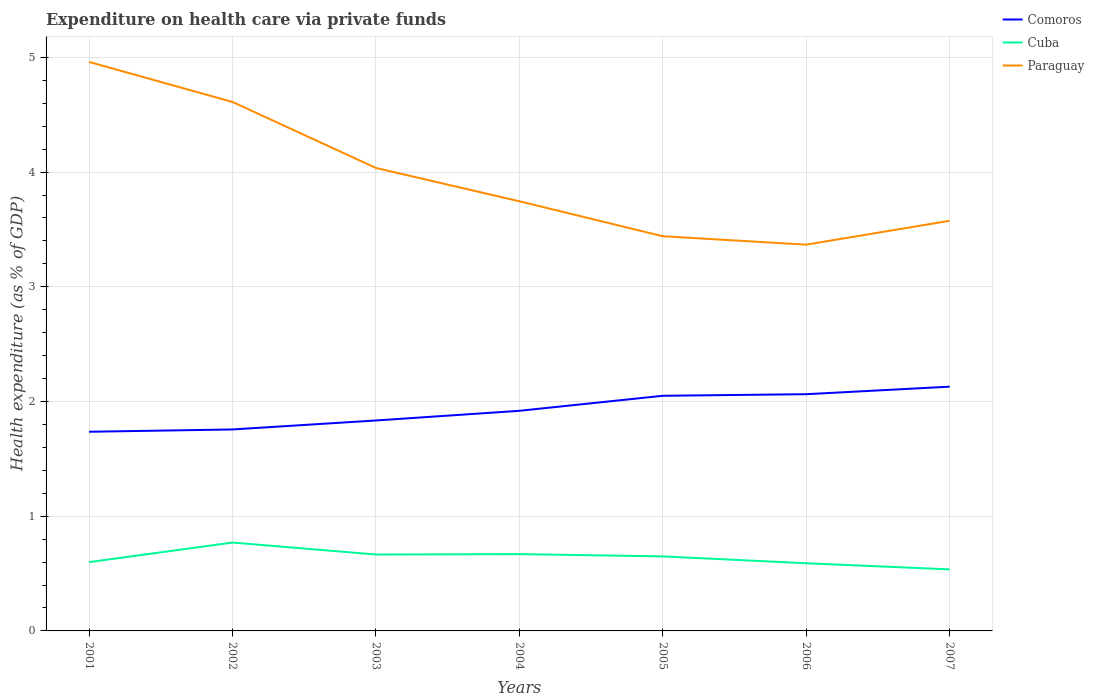How many different coloured lines are there?
Give a very brief answer. 3. Is the number of lines equal to the number of legend labels?
Provide a succinct answer. Yes. Across all years, what is the maximum expenditure made on health care in Comoros?
Your answer should be compact. 1.74. What is the total expenditure made on health care in Paraguay in the graph?
Provide a short and direct response. 1.21. What is the difference between the highest and the second highest expenditure made on health care in Cuba?
Ensure brevity in your answer.  0.23. How many lines are there?
Your response must be concise. 3. How many years are there in the graph?
Make the answer very short. 7. What is the difference between two consecutive major ticks on the Y-axis?
Make the answer very short. 1. Are the values on the major ticks of Y-axis written in scientific E-notation?
Keep it short and to the point. No. Does the graph contain any zero values?
Ensure brevity in your answer.  No. Does the graph contain grids?
Provide a succinct answer. Yes. How many legend labels are there?
Your answer should be compact. 3. How are the legend labels stacked?
Ensure brevity in your answer.  Vertical. What is the title of the graph?
Keep it short and to the point. Expenditure on health care via private funds. What is the label or title of the X-axis?
Give a very brief answer. Years. What is the label or title of the Y-axis?
Give a very brief answer. Health expenditure (as % of GDP). What is the Health expenditure (as % of GDP) in Comoros in 2001?
Provide a succinct answer. 1.74. What is the Health expenditure (as % of GDP) in Cuba in 2001?
Provide a short and direct response. 0.6. What is the Health expenditure (as % of GDP) of Paraguay in 2001?
Offer a terse response. 4.96. What is the Health expenditure (as % of GDP) of Comoros in 2002?
Offer a very short reply. 1.76. What is the Health expenditure (as % of GDP) in Cuba in 2002?
Your response must be concise. 0.77. What is the Health expenditure (as % of GDP) in Paraguay in 2002?
Ensure brevity in your answer.  4.61. What is the Health expenditure (as % of GDP) of Comoros in 2003?
Your response must be concise. 1.83. What is the Health expenditure (as % of GDP) in Cuba in 2003?
Provide a succinct answer. 0.67. What is the Health expenditure (as % of GDP) of Paraguay in 2003?
Offer a terse response. 4.04. What is the Health expenditure (as % of GDP) of Comoros in 2004?
Offer a terse response. 1.92. What is the Health expenditure (as % of GDP) in Cuba in 2004?
Offer a terse response. 0.67. What is the Health expenditure (as % of GDP) in Paraguay in 2004?
Give a very brief answer. 3.75. What is the Health expenditure (as % of GDP) in Comoros in 2005?
Ensure brevity in your answer.  2.05. What is the Health expenditure (as % of GDP) of Cuba in 2005?
Ensure brevity in your answer.  0.65. What is the Health expenditure (as % of GDP) of Paraguay in 2005?
Your answer should be very brief. 3.44. What is the Health expenditure (as % of GDP) in Comoros in 2006?
Make the answer very short. 2.06. What is the Health expenditure (as % of GDP) of Cuba in 2006?
Your answer should be very brief. 0.59. What is the Health expenditure (as % of GDP) of Paraguay in 2006?
Keep it short and to the point. 3.37. What is the Health expenditure (as % of GDP) of Comoros in 2007?
Provide a succinct answer. 2.13. What is the Health expenditure (as % of GDP) in Cuba in 2007?
Ensure brevity in your answer.  0.54. What is the Health expenditure (as % of GDP) of Paraguay in 2007?
Keep it short and to the point. 3.58. Across all years, what is the maximum Health expenditure (as % of GDP) in Comoros?
Your answer should be compact. 2.13. Across all years, what is the maximum Health expenditure (as % of GDP) of Cuba?
Provide a short and direct response. 0.77. Across all years, what is the maximum Health expenditure (as % of GDP) in Paraguay?
Provide a short and direct response. 4.96. Across all years, what is the minimum Health expenditure (as % of GDP) of Comoros?
Your answer should be very brief. 1.74. Across all years, what is the minimum Health expenditure (as % of GDP) in Cuba?
Give a very brief answer. 0.54. Across all years, what is the minimum Health expenditure (as % of GDP) in Paraguay?
Provide a short and direct response. 3.37. What is the total Health expenditure (as % of GDP) in Comoros in the graph?
Make the answer very short. 13.49. What is the total Health expenditure (as % of GDP) of Cuba in the graph?
Provide a short and direct response. 4.48. What is the total Health expenditure (as % of GDP) in Paraguay in the graph?
Make the answer very short. 27.74. What is the difference between the Health expenditure (as % of GDP) of Comoros in 2001 and that in 2002?
Give a very brief answer. -0.02. What is the difference between the Health expenditure (as % of GDP) in Cuba in 2001 and that in 2002?
Give a very brief answer. -0.17. What is the difference between the Health expenditure (as % of GDP) of Paraguay in 2001 and that in 2002?
Offer a very short reply. 0.35. What is the difference between the Health expenditure (as % of GDP) of Comoros in 2001 and that in 2003?
Offer a very short reply. -0.1. What is the difference between the Health expenditure (as % of GDP) in Cuba in 2001 and that in 2003?
Your answer should be very brief. -0.07. What is the difference between the Health expenditure (as % of GDP) of Paraguay in 2001 and that in 2003?
Make the answer very short. 0.92. What is the difference between the Health expenditure (as % of GDP) of Comoros in 2001 and that in 2004?
Ensure brevity in your answer.  -0.18. What is the difference between the Health expenditure (as % of GDP) of Cuba in 2001 and that in 2004?
Ensure brevity in your answer.  -0.07. What is the difference between the Health expenditure (as % of GDP) of Paraguay in 2001 and that in 2004?
Ensure brevity in your answer.  1.21. What is the difference between the Health expenditure (as % of GDP) of Comoros in 2001 and that in 2005?
Ensure brevity in your answer.  -0.31. What is the difference between the Health expenditure (as % of GDP) in Cuba in 2001 and that in 2005?
Offer a very short reply. -0.05. What is the difference between the Health expenditure (as % of GDP) in Paraguay in 2001 and that in 2005?
Give a very brief answer. 1.52. What is the difference between the Health expenditure (as % of GDP) of Comoros in 2001 and that in 2006?
Your answer should be very brief. -0.33. What is the difference between the Health expenditure (as % of GDP) in Cuba in 2001 and that in 2006?
Keep it short and to the point. 0.01. What is the difference between the Health expenditure (as % of GDP) in Paraguay in 2001 and that in 2006?
Ensure brevity in your answer.  1.59. What is the difference between the Health expenditure (as % of GDP) of Comoros in 2001 and that in 2007?
Give a very brief answer. -0.39. What is the difference between the Health expenditure (as % of GDP) of Cuba in 2001 and that in 2007?
Ensure brevity in your answer.  0.06. What is the difference between the Health expenditure (as % of GDP) of Paraguay in 2001 and that in 2007?
Give a very brief answer. 1.38. What is the difference between the Health expenditure (as % of GDP) in Comoros in 2002 and that in 2003?
Your answer should be very brief. -0.08. What is the difference between the Health expenditure (as % of GDP) of Cuba in 2002 and that in 2003?
Keep it short and to the point. 0.1. What is the difference between the Health expenditure (as % of GDP) in Paraguay in 2002 and that in 2003?
Keep it short and to the point. 0.58. What is the difference between the Health expenditure (as % of GDP) in Comoros in 2002 and that in 2004?
Offer a terse response. -0.16. What is the difference between the Health expenditure (as % of GDP) of Cuba in 2002 and that in 2004?
Keep it short and to the point. 0.1. What is the difference between the Health expenditure (as % of GDP) in Paraguay in 2002 and that in 2004?
Provide a succinct answer. 0.87. What is the difference between the Health expenditure (as % of GDP) in Comoros in 2002 and that in 2005?
Give a very brief answer. -0.29. What is the difference between the Health expenditure (as % of GDP) in Cuba in 2002 and that in 2005?
Provide a succinct answer. 0.12. What is the difference between the Health expenditure (as % of GDP) in Paraguay in 2002 and that in 2005?
Make the answer very short. 1.17. What is the difference between the Health expenditure (as % of GDP) in Comoros in 2002 and that in 2006?
Ensure brevity in your answer.  -0.31. What is the difference between the Health expenditure (as % of GDP) in Cuba in 2002 and that in 2006?
Give a very brief answer. 0.18. What is the difference between the Health expenditure (as % of GDP) of Paraguay in 2002 and that in 2006?
Keep it short and to the point. 1.24. What is the difference between the Health expenditure (as % of GDP) of Comoros in 2002 and that in 2007?
Offer a very short reply. -0.37. What is the difference between the Health expenditure (as % of GDP) of Cuba in 2002 and that in 2007?
Provide a succinct answer. 0.23. What is the difference between the Health expenditure (as % of GDP) of Paraguay in 2002 and that in 2007?
Your answer should be very brief. 1.04. What is the difference between the Health expenditure (as % of GDP) of Comoros in 2003 and that in 2004?
Provide a succinct answer. -0.08. What is the difference between the Health expenditure (as % of GDP) of Cuba in 2003 and that in 2004?
Offer a terse response. -0. What is the difference between the Health expenditure (as % of GDP) of Paraguay in 2003 and that in 2004?
Provide a short and direct response. 0.29. What is the difference between the Health expenditure (as % of GDP) of Comoros in 2003 and that in 2005?
Offer a terse response. -0.22. What is the difference between the Health expenditure (as % of GDP) in Cuba in 2003 and that in 2005?
Your answer should be compact. 0.02. What is the difference between the Health expenditure (as % of GDP) in Paraguay in 2003 and that in 2005?
Make the answer very short. 0.6. What is the difference between the Health expenditure (as % of GDP) of Comoros in 2003 and that in 2006?
Ensure brevity in your answer.  -0.23. What is the difference between the Health expenditure (as % of GDP) of Cuba in 2003 and that in 2006?
Your answer should be very brief. 0.08. What is the difference between the Health expenditure (as % of GDP) in Paraguay in 2003 and that in 2006?
Your answer should be compact. 0.67. What is the difference between the Health expenditure (as % of GDP) of Comoros in 2003 and that in 2007?
Offer a very short reply. -0.29. What is the difference between the Health expenditure (as % of GDP) of Cuba in 2003 and that in 2007?
Provide a short and direct response. 0.13. What is the difference between the Health expenditure (as % of GDP) in Paraguay in 2003 and that in 2007?
Your response must be concise. 0.46. What is the difference between the Health expenditure (as % of GDP) of Comoros in 2004 and that in 2005?
Ensure brevity in your answer.  -0.13. What is the difference between the Health expenditure (as % of GDP) of Cuba in 2004 and that in 2005?
Your response must be concise. 0.02. What is the difference between the Health expenditure (as % of GDP) in Paraguay in 2004 and that in 2005?
Offer a terse response. 0.3. What is the difference between the Health expenditure (as % of GDP) in Comoros in 2004 and that in 2006?
Ensure brevity in your answer.  -0.14. What is the difference between the Health expenditure (as % of GDP) in Cuba in 2004 and that in 2006?
Make the answer very short. 0.08. What is the difference between the Health expenditure (as % of GDP) in Paraguay in 2004 and that in 2006?
Give a very brief answer. 0.38. What is the difference between the Health expenditure (as % of GDP) of Comoros in 2004 and that in 2007?
Provide a short and direct response. -0.21. What is the difference between the Health expenditure (as % of GDP) in Cuba in 2004 and that in 2007?
Ensure brevity in your answer.  0.13. What is the difference between the Health expenditure (as % of GDP) of Paraguay in 2004 and that in 2007?
Provide a succinct answer. 0.17. What is the difference between the Health expenditure (as % of GDP) in Comoros in 2005 and that in 2006?
Offer a very short reply. -0.01. What is the difference between the Health expenditure (as % of GDP) of Cuba in 2005 and that in 2006?
Offer a terse response. 0.06. What is the difference between the Health expenditure (as % of GDP) of Paraguay in 2005 and that in 2006?
Give a very brief answer. 0.07. What is the difference between the Health expenditure (as % of GDP) in Comoros in 2005 and that in 2007?
Provide a succinct answer. -0.08. What is the difference between the Health expenditure (as % of GDP) of Cuba in 2005 and that in 2007?
Provide a succinct answer. 0.11. What is the difference between the Health expenditure (as % of GDP) of Paraguay in 2005 and that in 2007?
Offer a terse response. -0.13. What is the difference between the Health expenditure (as % of GDP) in Comoros in 2006 and that in 2007?
Your answer should be very brief. -0.07. What is the difference between the Health expenditure (as % of GDP) of Cuba in 2006 and that in 2007?
Provide a succinct answer. 0.05. What is the difference between the Health expenditure (as % of GDP) in Paraguay in 2006 and that in 2007?
Your response must be concise. -0.21. What is the difference between the Health expenditure (as % of GDP) of Comoros in 2001 and the Health expenditure (as % of GDP) of Cuba in 2002?
Ensure brevity in your answer.  0.97. What is the difference between the Health expenditure (as % of GDP) in Comoros in 2001 and the Health expenditure (as % of GDP) in Paraguay in 2002?
Ensure brevity in your answer.  -2.88. What is the difference between the Health expenditure (as % of GDP) of Cuba in 2001 and the Health expenditure (as % of GDP) of Paraguay in 2002?
Offer a terse response. -4.01. What is the difference between the Health expenditure (as % of GDP) of Comoros in 2001 and the Health expenditure (as % of GDP) of Cuba in 2003?
Make the answer very short. 1.07. What is the difference between the Health expenditure (as % of GDP) of Comoros in 2001 and the Health expenditure (as % of GDP) of Paraguay in 2003?
Offer a terse response. -2.3. What is the difference between the Health expenditure (as % of GDP) in Cuba in 2001 and the Health expenditure (as % of GDP) in Paraguay in 2003?
Provide a succinct answer. -3.44. What is the difference between the Health expenditure (as % of GDP) of Comoros in 2001 and the Health expenditure (as % of GDP) of Cuba in 2004?
Provide a short and direct response. 1.07. What is the difference between the Health expenditure (as % of GDP) of Comoros in 2001 and the Health expenditure (as % of GDP) of Paraguay in 2004?
Offer a very short reply. -2.01. What is the difference between the Health expenditure (as % of GDP) in Cuba in 2001 and the Health expenditure (as % of GDP) in Paraguay in 2004?
Your response must be concise. -3.15. What is the difference between the Health expenditure (as % of GDP) in Comoros in 2001 and the Health expenditure (as % of GDP) in Cuba in 2005?
Keep it short and to the point. 1.09. What is the difference between the Health expenditure (as % of GDP) of Comoros in 2001 and the Health expenditure (as % of GDP) of Paraguay in 2005?
Offer a very short reply. -1.7. What is the difference between the Health expenditure (as % of GDP) in Cuba in 2001 and the Health expenditure (as % of GDP) in Paraguay in 2005?
Provide a succinct answer. -2.84. What is the difference between the Health expenditure (as % of GDP) of Comoros in 2001 and the Health expenditure (as % of GDP) of Cuba in 2006?
Provide a succinct answer. 1.15. What is the difference between the Health expenditure (as % of GDP) of Comoros in 2001 and the Health expenditure (as % of GDP) of Paraguay in 2006?
Keep it short and to the point. -1.63. What is the difference between the Health expenditure (as % of GDP) in Cuba in 2001 and the Health expenditure (as % of GDP) in Paraguay in 2006?
Provide a short and direct response. -2.77. What is the difference between the Health expenditure (as % of GDP) in Comoros in 2001 and the Health expenditure (as % of GDP) in Cuba in 2007?
Make the answer very short. 1.2. What is the difference between the Health expenditure (as % of GDP) of Comoros in 2001 and the Health expenditure (as % of GDP) of Paraguay in 2007?
Offer a very short reply. -1.84. What is the difference between the Health expenditure (as % of GDP) of Cuba in 2001 and the Health expenditure (as % of GDP) of Paraguay in 2007?
Your response must be concise. -2.98. What is the difference between the Health expenditure (as % of GDP) of Comoros in 2002 and the Health expenditure (as % of GDP) of Cuba in 2003?
Your answer should be very brief. 1.09. What is the difference between the Health expenditure (as % of GDP) in Comoros in 2002 and the Health expenditure (as % of GDP) in Paraguay in 2003?
Your answer should be very brief. -2.28. What is the difference between the Health expenditure (as % of GDP) of Cuba in 2002 and the Health expenditure (as % of GDP) of Paraguay in 2003?
Your answer should be very brief. -3.27. What is the difference between the Health expenditure (as % of GDP) in Comoros in 2002 and the Health expenditure (as % of GDP) in Cuba in 2004?
Give a very brief answer. 1.09. What is the difference between the Health expenditure (as % of GDP) of Comoros in 2002 and the Health expenditure (as % of GDP) of Paraguay in 2004?
Provide a succinct answer. -1.99. What is the difference between the Health expenditure (as % of GDP) of Cuba in 2002 and the Health expenditure (as % of GDP) of Paraguay in 2004?
Ensure brevity in your answer.  -2.98. What is the difference between the Health expenditure (as % of GDP) in Comoros in 2002 and the Health expenditure (as % of GDP) in Cuba in 2005?
Give a very brief answer. 1.11. What is the difference between the Health expenditure (as % of GDP) in Comoros in 2002 and the Health expenditure (as % of GDP) in Paraguay in 2005?
Offer a very short reply. -1.68. What is the difference between the Health expenditure (as % of GDP) in Cuba in 2002 and the Health expenditure (as % of GDP) in Paraguay in 2005?
Offer a terse response. -2.67. What is the difference between the Health expenditure (as % of GDP) of Comoros in 2002 and the Health expenditure (as % of GDP) of Cuba in 2006?
Offer a terse response. 1.17. What is the difference between the Health expenditure (as % of GDP) of Comoros in 2002 and the Health expenditure (as % of GDP) of Paraguay in 2006?
Your response must be concise. -1.61. What is the difference between the Health expenditure (as % of GDP) in Cuba in 2002 and the Health expenditure (as % of GDP) in Paraguay in 2006?
Your answer should be compact. -2.6. What is the difference between the Health expenditure (as % of GDP) in Comoros in 2002 and the Health expenditure (as % of GDP) in Cuba in 2007?
Keep it short and to the point. 1.22. What is the difference between the Health expenditure (as % of GDP) in Comoros in 2002 and the Health expenditure (as % of GDP) in Paraguay in 2007?
Ensure brevity in your answer.  -1.82. What is the difference between the Health expenditure (as % of GDP) of Cuba in 2002 and the Health expenditure (as % of GDP) of Paraguay in 2007?
Keep it short and to the point. -2.8. What is the difference between the Health expenditure (as % of GDP) of Comoros in 2003 and the Health expenditure (as % of GDP) of Cuba in 2004?
Give a very brief answer. 1.17. What is the difference between the Health expenditure (as % of GDP) of Comoros in 2003 and the Health expenditure (as % of GDP) of Paraguay in 2004?
Offer a terse response. -1.91. What is the difference between the Health expenditure (as % of GDP) in Cuba in 2003 and the Health expenditure (as % of GDP) in Paraguay in 2004?
Offer a very short reply. -3.08. What is the difference between the Health expenditure (as % of GDP) in Comoros in 2003 and the Health expenditure (as % of GDP) in Cuba in 2005?
Offer a very short reply. 1.18. What is the difference between the Health expenditure (as % of GDP) of Comoros in 2003 and the Health expenditure (as % of GDP) of Paraguay in 2005?
Give a very brief answer. -1.61. What is the difference between the Health expenditure (as % of GDP) of Cuba in 2003 and the Health expenditure (as % of GDP) of Paraguay in 2005?
Provide a short and direct response. -2.77. What is the difference between the Health expenditure (as % of GDP) of Comoros in 2003 and the Health expenditure (as % of GDP) of Cuba in 2006?
Ensure brevity in your answer.  1.24. What is the difference between the Health expenditure (as % of GDP) of Comoros in 2003 and the Health expenditure (as % of GDP) of Paraguay in 2006?
Provide a short and direct response. -1.53. What is the difference between the Health expenditure (as % of GDP) in Cuba in 2003 and the Health expenditure (as % of GDP) in Paraguay in 2006?
Offer a terse response. -2.7. What is the difference between the Health expenditure (as % of GDP) in Comoros in 2003 and the Health expenditure (as % of GDP) in Cuba in 2007?
Give a very brief answer. 1.3. What is the difference between the Health expenditure (as % of GDP) of Comoros in 2003 and the Health expenditure (as % of GDP) of Paraguay in 2007?
Make the answer very short. -1.74. What is the difference between the Health expenditure (as % of GDP) of Cuba in 2003 and the Health expenditure (as % of GDP) of Paraguay in 2007?
Offer a terse response. -2.91. What is the difference between the Health expenditure (as % of GDP) in Comoros in 2004 and the Health expenditure (as % of GDP) in Cuba in 2005?
Your answer should be compact. 1.27. What is the difference between the Health expenditure (as % of GDP) of Comoros in 2004 and the Health expenditure (as % of GDP) of Paraguay in 2005?
Provide a short and direct response. -1.52. What is the difference between the Health expenditure (as % of GDP) in Cuba in 2004 and the Health expenditure (as % of GDP) in Paraguay in 2005?
Make the answer very short. -2.77. What is the difference between the Health expenditure (as % of GDP) in Comoros in 2004 and the Health expenditure (as % of GDP) in Cuba in 2006?
Your answer should be compact. 1.33. What is the difference between the Health expenditure (as % of GDP) of Comoros in 2004 and the Health expenditure (as % of GDP) of Paraguay in 2006?
Offer a terse response. -1.45. What is the difference between the Health expenditure (as % of GDP) in Cuba in 2004 and the Health expenditure (as % of GDP) in Paraguay in 2006?
Provide a short and direct response. -2.7. What is the difference between the Health expenditure (as % of GDP) in Comoros in 2004 and the Health expenditure (as % of GDP) in Cuba in 2007?
Ensure brevity in your answer.  1.38. What is the difference between the Health expenditure (as % of GDP) in Comoros in 2004 and the Health expenditure (as % of GDP) in Paraguay in 2007?
Provide a short and direct response. -1.66. What is the difference between the Health expenditure (as % of GDP) in Cuba in 2004 and the Health expenditure (as % of GDP) in Paraguay in 2007?
Your answer should be very brief. -2.91. What is the difference between the Health expenditure (as % of GDP) of Comoros in 2005 and the Health expenditure (as % of GDP) of Cuba in 2006?
Make the answer very short. 1.46. What is the difference between the Health expenditure (as % of GDP) in Comoros in 2005 and the Health expenditure (as % of GDP) in Paraguay in 2006?
Make the answer very short. -1.32. What is the difference between the Health expenditure (as % of GDP) of Cuba in 2005 and the Health expenditure (as % of GDP) of Paraguay in 2006?
Make the answer very short. -2.72. What is the difference between the Health expenditure (as % of GDP) in Comoros in 2005 and the Health expenditure (as % of GDP) in Cuba in 2007?
Your answer should be very brief. 1.51. What is the difference between the Health expenditure (as % of GDP) in Comoros in 2005 and the Health expenditure (as % of GDP) in Paraguay in 2007?
Provide a short and direct response. -1.53. What is the difference between the Health expenditure (as % of GDP) of Cuba in 2005 and the Health expenditure (as % of GDP) of Paraguay in 2007?
Your answer should be very brief. -2.93. What is the difference between the Health expenditure (as % of GDP) in Comoros in 2006 and the Health expenditure (as % of GDP) in Cuba in 2007?
Give a very brief answer. 1.53. What is the difference between the Health expenditure (as % of GDP) of Comoros in 2006 and the Health expenditure (as % of GDP) of Paraguay in 2007?
Your response must be concise. -1.51. What is the difference between the Health expenditure (as % of GDP) of Cuba in 2006 and the Health expenditure (as % of GDP) of Paraguay in 2007?
Make the answer very short. -2.99. What is the average Health expenditure (as % of GDP) in Comoros per year?
Your answer should be compact. 1.93. What is the average Health expenditure (as % of GDP) of Cuba per year?
Make the answer very short. 0.64. What is the average Health expenditure (as % of GDP) of Paraguay per year?
Your response must be concise. 3.96. In the year 2001, what is the difference between the Health expenditure (as % of GDP) of Comoros and Health expenditure (as % of GDP) of Cuba?
Your response must be concise. 1.14. In the year 2001, what is the difference between the Health expenditure (as % of GDP) in Comoros and Health expenditure (as % of GDP) in Paraguay?
Provide a short and direct response. -3.22. In the year 2001, what is the difference between the Health expenditure (as % of GDP) of Cuba and Health expenditure (as % of GDP) of Paraguay?
Your answer should be very brief. -4.36. In the year 2002, what is the difference between the Health expenditure (as % of GDP) in Comoros and Health expenditure (as % of GDP) in Cuba?
Offer a very short reply. 0.99. In the year 2002, what is the difference between the Health expenditure (as % of GDP) in Comoros and Health expenditure (as % of GDP) in Paraguay?
Your response must be concise. -2.85. In the year 2002, what is the difference between the Health expenditure (as % of GDP) in Cuba and Health expenditure (as % of GDP) in Paraguay?
Provide a short and direct response. -3.84. In the year 2003, what is the difference between the Health expenditure (as % of GDP) in Comoros and Health expenditure (as % of GDP) in Cuba?
Provide a succinct answer. 1.17. In the year 2003, what is the difference between the Health expenditure (as % of GDP) of Comoros and Health expenditure (as % of GDP) of Paraguay?
Keep it short and to the point. -2.2. In the year 2003, what is the difference between the Health expenditure (as % of GDP) of Cuba and Health expenditure (as % of GDP) of Paraguay?
Provide a short and direct response. -3.37. In the year 2004, what is the difference between the Health expenditure (as % of GDP) in Comoros and Health expenditure (as % of GDP) in Cuba?
Offer a very short reply. 1.25. In the year 2004, what is the difference between the Health expenditure (as % of GDP) of Comoros and Health expenditure (as % of GDP) of Paraguay?
Provide a short and direct response. -1.83. In the year 2004, what is the difference between the Health expenditure (as % of GDP) of Cuba and Health expenditure (as % of GDP) of Paraguay?
Offer a very short reply. -3.08. In the year 2005, what is the difference between the Health expenditure (as % of GDP) in Comoros and Health expenditure (as % of GDP) in Cuba?
Ensure brevity in your answer.  1.4. In the year 2005, what is the difference between the Health expenditure (as % of GDP) of Comoros and Health expenditure (as % of GDP) of Paraguay?
Ensure brevity in your answer.  -1.39. In the year 2005, what is the difference between the Health expenditure (as % of GDP) of Cuba and Health expenditure (as % of GDP) of Paraguay?
Ensure brevity in your answer.  -2.79. In the year 2006, what is the difference between the Health expenditure (as % of GDP) in Comoros and Health expenditure (as % of GDP) in Cuba?
Your response must be concise. 1.47. In the year 2006, what is the difference between the Health expenditure (as % of GDP) in Comoros and Health expenditure (as % of GDP) in Paraguay?
Make the answer very short. -1.3. In the year 2006, what is the difference between the Health expenditure (as % of GDP) in Cuba and Health expenditure (as % of GDP) in Paraguay?
Offer a terse response. -2.78. In the year 2007, what is the difference between the Health expenditure (as % of GDP) of Comoros and Health expenditure (as % of GDP) of Cuba?
Provide a succinct answer. 1.59. In the year 2007, what is the difference between the Health expenditure (as % of GDP) in Comoros and Health expenditure (as % of GDP) in Paraguay?
Your answer should be compact. -1.45. In the year 2007, what is the difference between the Health expenditure (as % of GDP) in Cuba and Health expenditure (as % of GDP) in Paraguay?
Give a very brief answer. -3.04. What is the ratio of the Health expenditure (as % of GDP) of Cuba in 2001 to that in 2002?
Ensure brevity in your answer.  0.78. What is the ratio of the Health expenditure (as % of GDP) in Paraguay in 2001 to that in 2002?
Make the answer very short. 1.08. What is the ratio of the Health expenditure (as % of GDP) in Comoros in 2001 to that in 2003?
Make the answer very short. 0.95. What is the ratio of the Health expenditure (as % of GDP) of Cuba in 2001 to that in 2003?
Your answer should be very brief. 0.9. What is the ratio of the Health expenditure (as % of GDP) in Paraguay in 2001 to that in 2003?
Keep it short and to the point. 1.23. What is the ratio of the Health expenditure (as % of GDP) of Comoros in 2001 to that in 2004?
Offer a terse response. 0.9. What is the ratio of the Health expenditure (as % of GDP) of Cuba in 2001 to that in 2004?
Make the answer very short. 0.9. What is the ratio of the Health expenditure (as % of GDP) of Paraguay in 2001 to that in 2004?
Offer a very short reply. 1.32. What is the ratio of the Health expenditure (as % of GDP) of Comoros in 2001 to that in 2005?
Your answer should be compact. 0.85. What is the ratio of the Health expenditure (as % of GDP) of Cuba in 2001 to that in 2005?
Keep it short and to the point. 0.92. What is the ratio of the Health expenditure (as % of GDP) of Paraguay in 2001 to that in 2005?
Offer a terse response. 1.44. What is the ratio of the Health expenditure (as % of GDP) in Comoros in 2001 to that in 2006?
Make the answer very short. 0.84. What is the ratio of the Health expenditure (as % of GDP) of Cuba in 2001 to that in 2006?
Your answer should be very brief. 1.02. What is the ratio of the Health expenditure (as % of GDP) in Paraguay in 2001 to that in 2006?
Your response must be concise. 1.47. What is the ratio of the Health expenditure (as % of GDP) of Comoros in 2001 to that in 2007?
Give a very brief answer. 0.82. What is the ratio of the Health expenditure (as % of GDP) of Cuba in 2001 to that in 2007?
Offer a terse response. 1.12. What is the ratio of the Health expenditure (as % of GDP) in Paraguay in 2001 to that in 2007?
Keep it short and to the point. 1.39. What is the ratio of the Health expenditure (as % of GDP) of Comoros in 2002 to that in 2003?
Your answer should be compact. 0.96. What is the ratio of the Health expenditure (as % of GDP) in Cuba in 2002 to that in 2003?
Make the answer very short. 1.16. What is the ratio of the Health expenditure (as % of GDP) in Paraguay in 2002 to that in 2003?
Offer a very short reply. 1.14. What is the ratio of the Health expenditure (as % of GDP) in Comoros in 2002 to that in 2004?
Make the answer very short. 0.92. What is the ratio of the Health expenditure (as % of GDP) in Cuba in 2002 to that in 2004?
Keep it short and to the point. 1.15. What is the ratio of the Health expenditure (as % of GDP) in Paraguay in 2002 to that in 2004?
Provide a short and direct response. 1.23. What is the ratio of the Health expenditure (as % of GDP) of Comoros in 2002 to that in 2005?
Ensure brevity in your answer.  0.86. What is the ratio of the Health expenditure (as % of GDP) in Cuba in 2002 to that in 2005?
Give a very brief answer. 1.19. What is the ratio of the Health expenditure (as % of GDP) in Paraguay in 2002 to that in 2005?
Offer a terse response. 1.34. What is the ratio of the Health expenditure (as % of GDP) in Comoros in 2002 to that in 2006?
Your response must be concise. 0.85. What is the ratio of the Health expenditure (as % of GDP) in Cuba in 2002 to that in 2006?
Your response must be concise. 1.31. What is the ratio of the Health expenditure (as % of GDP) of Paraguay in 2002 to that in 2006?
Keep it short and to the point. 1.37. What is the ratio of the Health expenditure (as % of GDP) in Comoros in 2002 to that in 2007?
Provide a short and direct response. 0.82. What is the ratio of the Health expenditure (as % of GDP) of Cuba in 2002 to that in 2007?
Give a very brief answer. 1.44. What is the ratio of the Health expenditure (as % of GDP) in Paraguay in 2002 to that in 2007?
Provide a short and direct response. 1.29. What is the ratio of the Health expenditure (as % of GDP) of Comoros in 2003 to that in 2004?
Make the answer very short. 0.96. What is the ratio of the Health expenditure (as % of GDP) in Cuba in 2003 to that in 2004?
Your answer should be compact. 0.99. What is the ratio of the Health expenditure (as % of GDP) of Paraguay in 2003 to that in 2004?
Provide a succinct answer. 1.08. What is the ratio of the Health expenditure (as % of GDP) in Comoros in 2003 to that in 2005?
Your response must be concise. 0.9. What is the ratio of the Health expenditure (as % of GDP) in Cuba in 2003 to that in 2005?
Give a very brief answer. 1.02. What is the ratio of the Health expenditure (as % of GDP) of Paraguay in 2003 to that in 2005?
Keep it short and to the point. 1.17. What is the ratio of the Health expenditure (as % of GDP) in Comoros in 2003 to that in 2006?
Your answer should be compact. 0.89. What is the ratio of the Health expenditure (as % of GDP) in Cuba in 2003 to that in 2006?
Provide a short and direct response. 1.13. What is the ratio of the Health expenditure (as % of GDP) in Paraguay in 2003 to that in 2006?
Give a very brief answer. 1.2. What is the ratio of the Health expenditure (as % of GDP) in Comoros in 2003 to that in 2007?
Provide a short and direct response. 0.86. What is the ratio of the Health expenditure (as % of GDP) in Cuba in 2003 to that in 2007?
Make the answer very short. 1.24. What is the ratio of the Health expenditure (as % of GDP) in Paraguay in 2003 to that in 2007?
Make the answer very short. 1.13. What is the ratio of the Health expenditure (as % of GDP) in Comoros in 2004 to that in 2005?
Your response must be concise. 0.94. What is the ratio of the Health expenditure (as % of GDP) in Cuba in 2004 to that in 2005?
Offer a very short reply. 1.03. What is the ratio of the Health expenditure (as % of GDP) in Paraguay in 2004 to that in 2005?
Keep it short and to the point. 1.09. What is the ratio of the Health expenditure (as % of GDP) in Comoros in 2004 to that in 2006?
Offer a very short reply. 0.93. What is the ratio of the Health expenditure (as % of GDP) of Cuba in 2004 to that in 2006?
Provide a succinct answer. 1.13. What is the ratio of the Health expenditure (as % of GDP) in Paraguay in 2004 to that in 2006?
Make the answer very short. 1.11. What is the ratio of the Health expenditure (as % of GDP) in Comoros in 2004 to that in 2007?
Keep it short and to the point. 0.9. What is the ratio of the Health expenditure (as % of GDP) of Cuba in 2004 to that in 2007?
Ensure brevity in your answer.  1.25. What is the ratio of the Health expenditure (as % of GDP) in Paraguay in 2004 to that in 2007?
Make the answer very short. 1.05. What is the ratio of the Health expenditure (as % of GDP) in Comoros in 2005 to that in 2006?
Provide a succinct answer. 0.99. What is the ratio of the Health expenditure (as % of GDP) in Cuba in 2005 to that in 2006?
Keep it short and to the point. 1.1. What is the ratio of the Health expenditure (as % of GDP) in Paraguay in 2005 to that in 2006?
Your answer should be very brief. 1.02. What is the ratio of the Health expenditure (as % of GDP) of Comoros in 2005 to that in 2007?
Provide a short and direct response. 0.96. What is the ratio of the Health expenditure (as % of GDP) in Cuba in 2005 to that in 2007?
Provide a short and direct response. 1.21. What is the ratio of the Health expenditure (as % of GDP) in Paraguay in 2005 to that in 2007?
Keep it short and to the point. 0.96. What is the ratio of the Health expenditure (as % of GDP) of Comoros in 2006 to that in 2007?
Ensure brevity in your answer.  0.97. What is the ratio of the Health expenditure (as % of GDP) of Cuba in 2006 to that in 2007?
Offer a very short reply. 1.1. What is the ratio of the Health expenditure (as % of GDP) in Paraguay in 2006 to that in 2007?
Provide a succinct answer. 0.94. What is the difference between the highest and the second highest Health expenditure (as % of GDP) in Comoros?
Make the answer very short. 0.07. What is the difference between the highest and the second highest Health expenditure (as % of GDP) of Cuba?
Make the answer very short. 0.1. What is the difference between the highest and the second highest Health expenditure (as % of GDP) of Paraguay?
Give a very brief answer. 0.35. What is the difference between the highest and the lowest Health expenditure (as % of GDP) of Comoros?
Make the answer very short. 0.39. What is the difference between the highest and the lowest Health expenditure (as % of GDP) in Cuba?
Your response must be concise. 0.23. What is the difference between the highest and the lowest Health expenditure (as % of GDP) of Paraguay?
Offer a terse response. 1.59. 